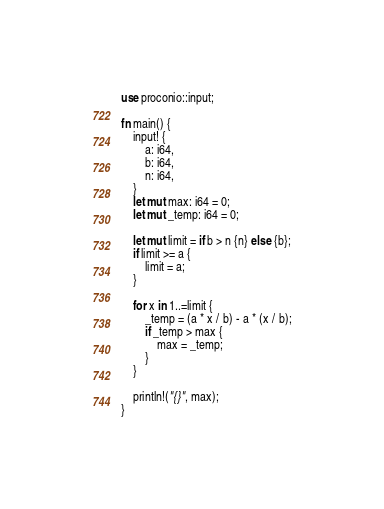Convert code to text. <code><loc_0><loc_0><loc_500><loc_500><_Rust_>use proconio::input;

fn main() {
    input! {
        a: i64,
        b: i64,
        n: i64,
    }
    let mut max: i64 = 0;
    let mut _temp: i64 = 0;

    let mut limit = if b > n {n} else {b};
    if limit >= a {
        limit = a;
    }

    for x in 1..=limit {
        _temp = (a * x / b) - a * (x / b);
        if _temp > max {
            max = _temp;
        }
    }

    println!("{}", max);
}</code> 